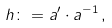<formula> <loc_0><loc_0><loc_500><loc_500>h \colon = a ^ { \prime } \cdot a ^ { - 1 } \, ,</formula> 